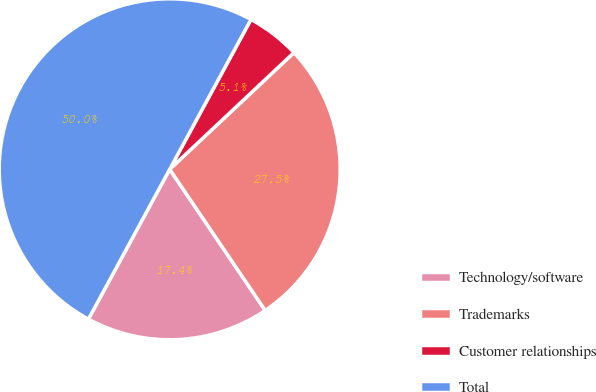Convert chart. <chart><loc_0><loc_0><loc_500><loc_500><pie_chart><fcel>Technology/software<fcel>Trademarks<fcel>Customer relationships<fcel>Total<nl><fcel>17.38%<fcel>27.53%<fcel>5.09%<fcel>50.0%<nl></chart> 